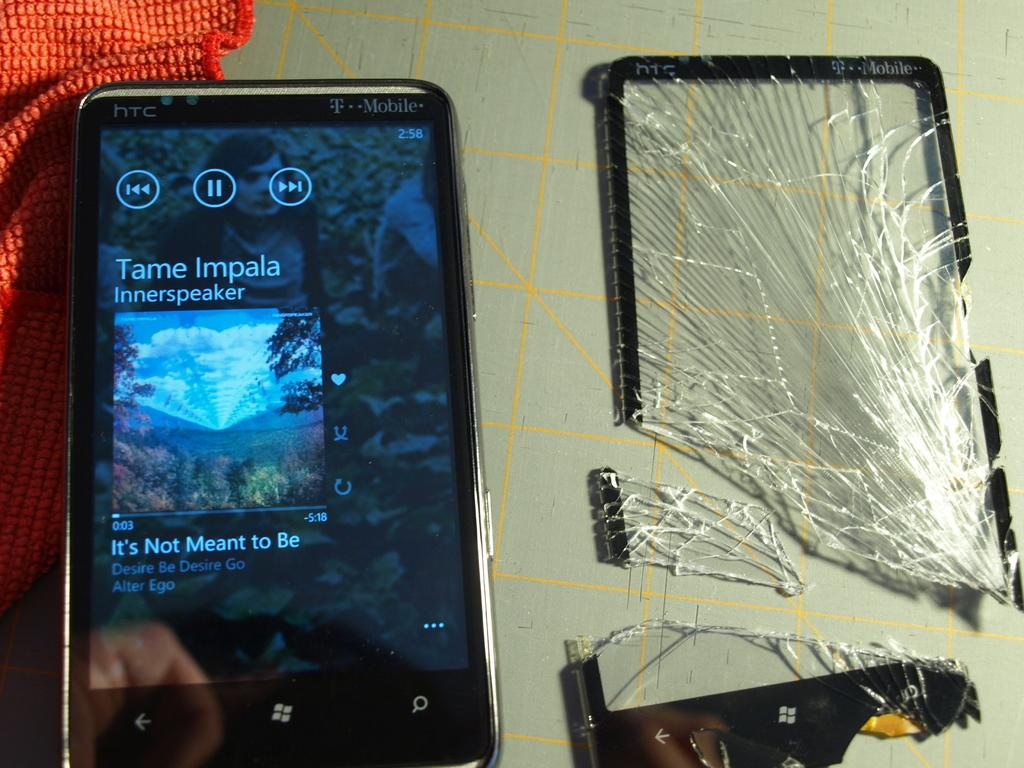<image>
Describe the image concisely. A shattered phone screen next to a phone playing Tame Impala. 